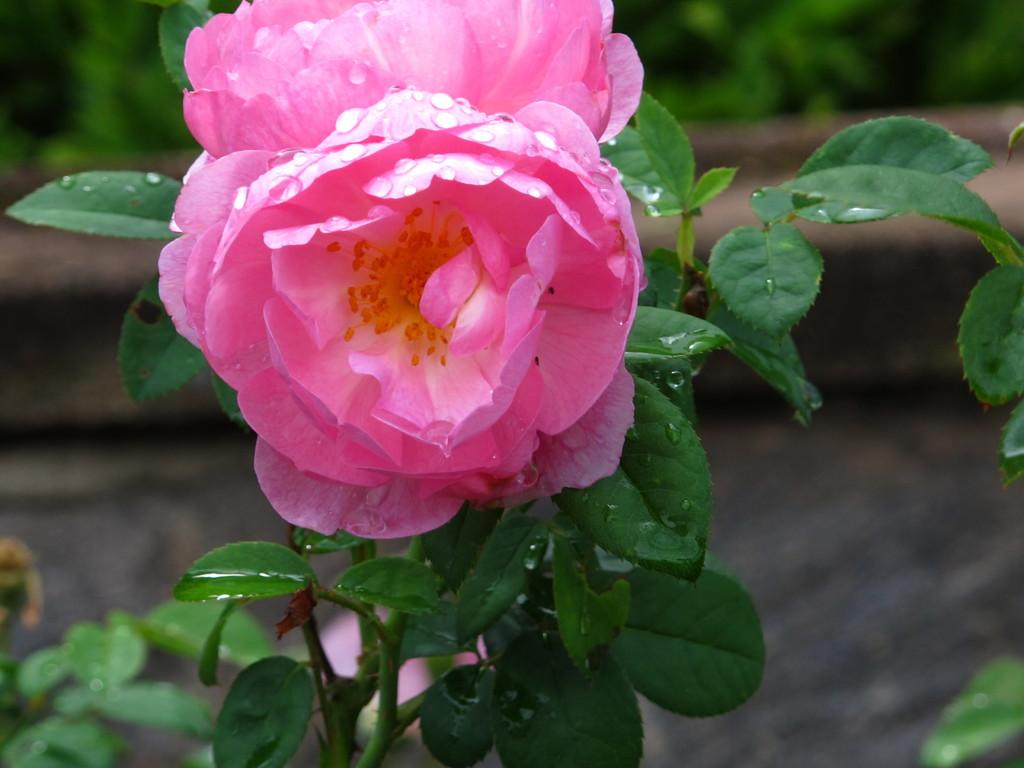What type of plant is featured in the image? The plant in the image has flowers on it. Can you describe the background of the image? There are additional plants visible in the background of the image. What type of police account is mentioned in the image? There is no mention of police or any accounts in the image; it features a plant with flowers and additional plants in the background. 